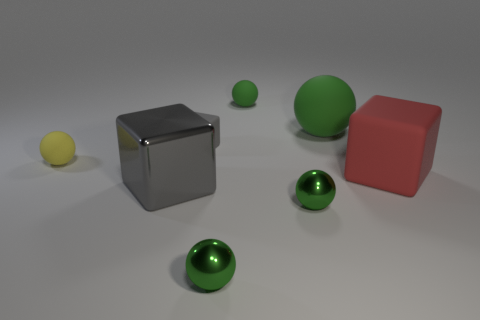What material is the large red cube?
Ensure brevity in your answer.  Rubber. Do the small yellow ball and the big green ball that is behind the gray shiny block have the same material?
Provide a short and direct response. Yes. Are there any other things that have the same color as the large rubber cube?
Give a very brief answer. No. Is there a rubber cube in front of the object that is on the left side of the block in front of the red rubber object?
Your response must be concise. Yes. The large rubber cube is what color?
Offer a terse response. Red. There is a gray metal object; are there any green things behind it?
Make the answer very short. Yes. There is a yellow thing; is its shape the same as the small object that is behind the tiny block?
Keep it short and to the point. Yes. What number of other things are there of the same material as the large green ball
Make the answer very short. 4. What color is the small matte sphere to the right of the gray object in front of the matte ball that is to the left of the big gray metallic block?
Ensure brevity in your answer.  Green. What shape is the tiny green thing that is behind the sphere to the left of the tiny gray thing?
Your answer should be compact. Sphere. 